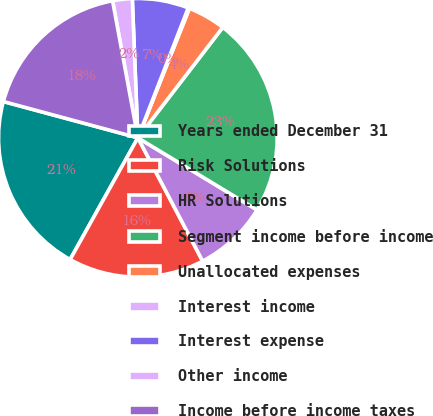Convert chart. <chart><loc_0><loc_0><loc_500><loc_500><pie_chart><fcel>Years ended December 31<fcel>Risk Solutions<fcel>HR Solutions<fcel>Segment income before income<fcel>Unallocated expenses<fcel>Interest income<fcel>Interest expense<fcel>Other income<fcel>Income before income taxes<nl><fcel>21.11%<fcel>15.78%<fcel>8.64%<fcel>23.23%<fcel>4.4%<fcel>0.15%<fcel>6.52%<fcel>2.27%<fcel>17.9%<nl></chart> 